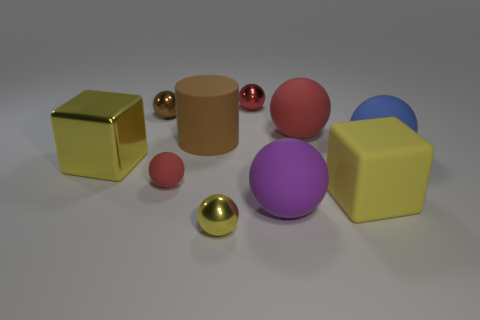Subtract all red balls. How many were subtracted if there are1red balls left? 2 Subtract all gray cylinders. How many red balls are left? 3 Subtract all red balls. How many balls are left? 4 Subtract all red rubber spheres. How many spheres are left? 5 Subtract all purple spheres. Subtract all gray cylinders. How many spheres are left? 6 Subtract all balls. How many objects are left? 3 Subtract 0 red cubes. How many objects are left? 10 Subtract all small gray matte spheres. Subtract all tiny yellow metallic balls. How many objects are left? 9 Add 4 small matte spheres. How many small matte spheres are left? 5 Add 5 red matte spheres. How many red matte spheres exist? 7 